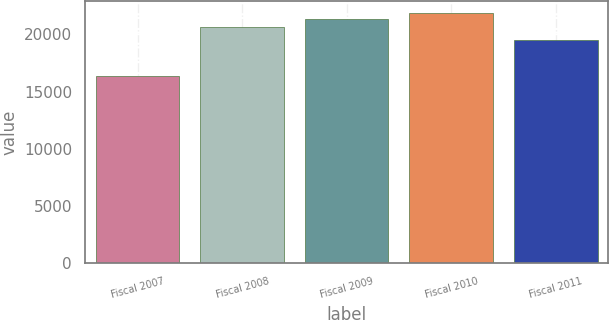Convert chart to OTSL. <chart><loc_0><loc_0><loc_500><loc_500><bar_chart><fcel>Fiscal 2007<fcel>Fiscal 2008<fcel>Fiscal 2009<fcel>Fiscal 2010<fcel>Fiscal 2011<nl><fcel>16377<fcel>20637<fcel>21316<fcel>21851.4<fcel>19518<nl></chart> 